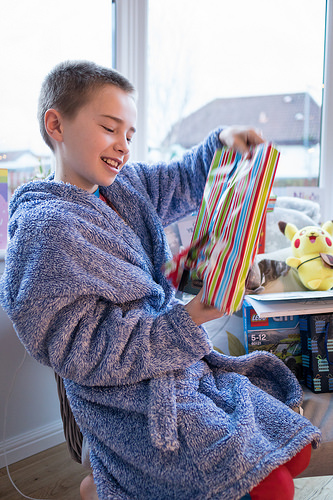<image>
Is the book in front of the lego? Yes. The book is positioned in front of the lego, appearing closer to the camera viewpoint. 